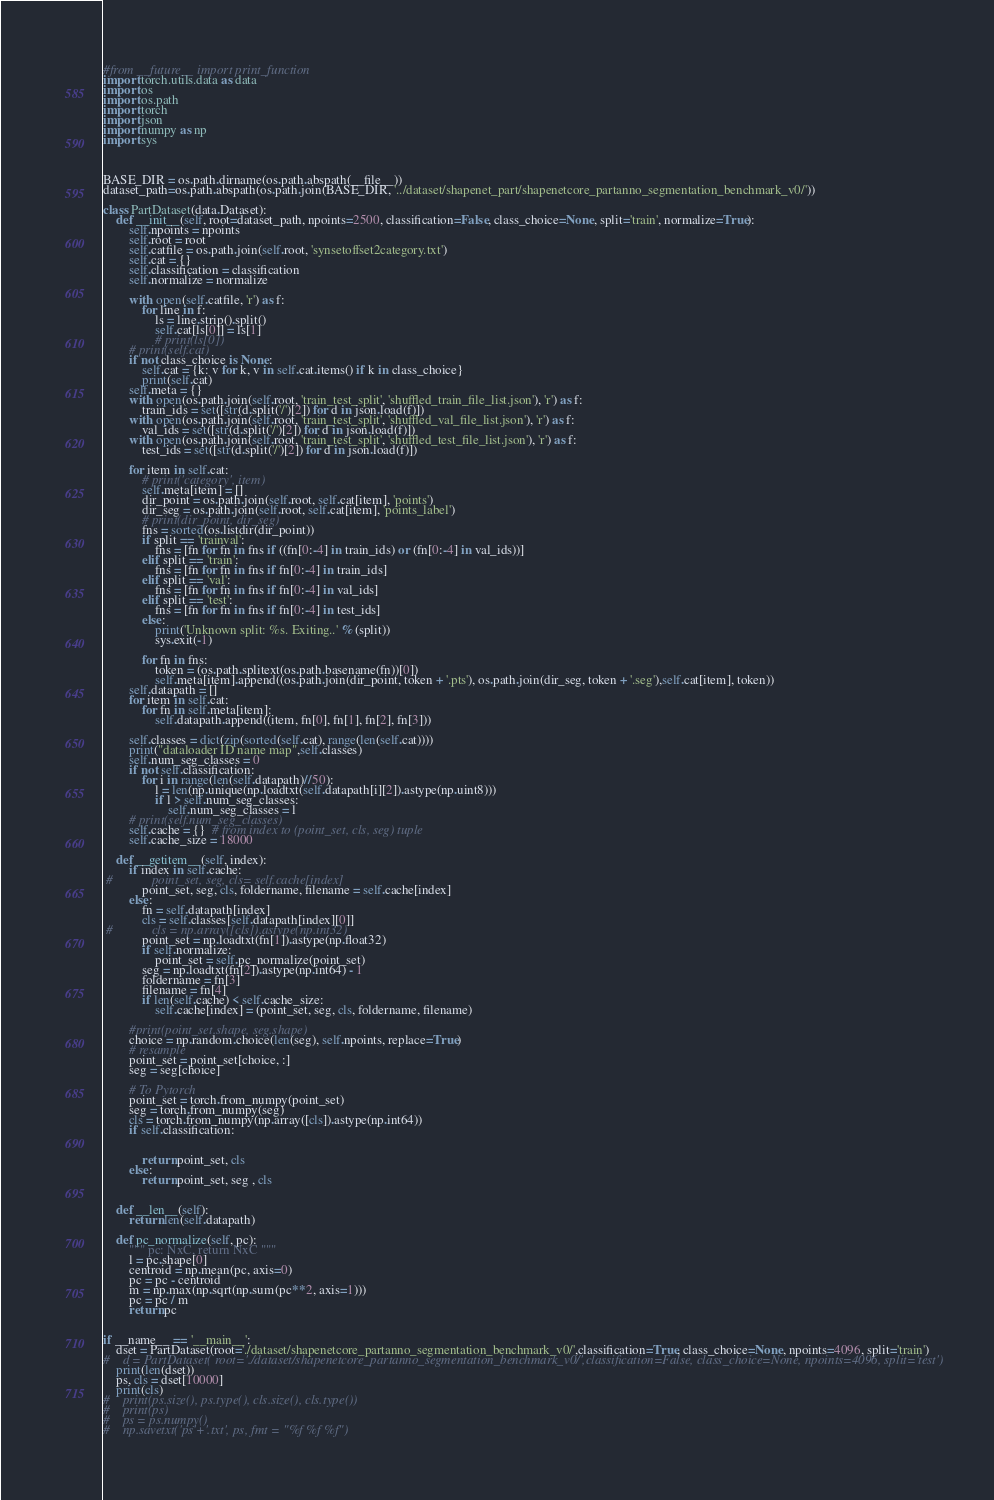<code> <loc_0><loc_0><loc_500><loc_500><_Python_>#from __future__ import print_function
import torch.utils.data as data
import os
import os.path
import torch
import json
import numpy as np
import sys



BASE_DIR = os.path.dirname(os.path.abspath(__file__))
dataset_path=os.path.abspath(os.path.join(BASE_DIR, '../dataset/shapenet_part/shapenetcore_partanno_segmentation_benchmark_v0/'))

class PartDataset(data.Dataset):
    def __init__(self, root=dataset_path, npoints=2500, classification=False, class_choice=None, split='train', normalize=True):
        self.npoints = npoints
        self.root = root
        self.catfile = os.path.join(self.root, 'synsetoffset2category.txt')
        self.cat = {}
        self.classification = classification
        self.normalize = normalize

        with open(self.catfile, 'r') as f:
            for line in f:
                ls = line.strip().split()
                self.cat[ls[0]] = ls[1]
                # print(ls[0])
        # print(self.cat)
        if not class_choice is None:
            self.cat = {k: v for k, v in self.cat.items() if k in class_choice}
            print(self.cat)
        self.meta = {}
        with open(os.path.join(self.root, 'train_test_split', 'shuffled_train_file_list.json'), 'r') as f:
            train_ids = set([str(d.split('/')[2]) for d in json.load(f)])
        with open(os.path.join(self.root, 'train_test_split', 'shuffled_val_file_list.json'), 'r') as f:
            val_ids = set([str(d.split('/')[2]) for d in json.load(f)])
        with open(os.path.join(self.root, 'train_test_split', 'shuffled_test_file_list.json'), 'r') as f:
            test_ids = set([str(d.split('/')[2]) for d in json.load(f)])

        for item in self.cat:
            # print('category', item)
            self.meta[item] = []
            dir_point = os.path.join(self.root, self.cat[item], 'points')
            dir_seg = os.path.join(self.root, self.cat[item], 'points_label')
            # print(dir_point, dir_seg)
            fns = sorted(os.listdir(dir_point))
            if split == 'trainval':
                fns = [fn for fn in fns if ((fn[0:-4] in train_ids) or (fn[0:-4] in val_ids))]
            elif split == 'train':
                fns = [fn for fn in fns if fn[0:-4] in train_ids]
            elif split == 'val':
                fns = [fn for fn in fns if fn[0:-4] in val_ids]
            elif split == 'test':
                fns = [fn for fn in fns if fn[0:-4] in test_ids]
            else:
                print('Unknown split: %s. Exiting..' % (split))
                sys.exit(-1)

            for fn in fns:
                token = (os.path.splitext(os.path.basename(fn))[0])
                self.meta[item].append((os.path.join(dir_point, token + '.pts'), os.path.join(dir_seg, token + '.seg'),self.cat[item], token))            
        self.datapath = []
        for item in self.cat:
            for fn in self.meta[item]:
                self.datapath.append((item, fn[0], fn[1], fn[2], fn[3]))

        self.classes = dict(zip(sorted(self.cat), range(len(self.cat))))
        print("dataloader ID name map",self.classes)
        self.num_seg_classes = 0
        if not self.classification:
            for i in range(len(self.datapath)//50):
                l = len(np.unique(np.loadtxt(self.datapath[i][2]).astype(np.uint8)))
                if l > self.num_seg_classes:
                    self.num_seg_classes = l
        # print(self.num_seg_classes)
        self.cache = {}  # from index to (point_set, cls, seg) tuple
        self.cache_size = 18000

    def __getitem__(self, index):
        if index in self.cache:
 #            point_set, seg, cls= self.cache[index]
            point_set, seg, cls, foldername, filename = self.cache[index]
        else:
            fn = self.datapath[index]
            cls = self.classes[self.datapath[index][0]]
 #            cls = np.array([cls]).astype(np.int32)
            point_set = np.loadtxt(fn[1]).astype(np.float32)
            if self.normalize:
                point_set = self.pc_normalize(point_set)
            seg = np.loadtxt(fn[2]).astype(np.int64) - 1
            foldername = fn[3]
            filename = fn[4]
            if len(self.cache) < self.cache_size:
                self.cache[index] = (point_set, seg, cls, foldername, filename)

        #print(point_set.shape, seg.shape)
        choice = np.random.choice(len(seg), self.npoints, replace=True)
        # resample
        point_set = point_set[choice, :]
        seg = seg[choice]
        
        # To Pytorch
        point_set = torch.from_numpy(point_set)
        seg = torch.from_numpy(seg)
        cls = torch.from_numpy(np.array([cls]).astype(np.int64))
        if self.classification:
            
            
            return point_set, cls
        else:
            return point_set, seg , cls
        

    def __len__(self):
        return len(self.datapath)
       
    def pc_normalize(self, pc):
        """ pc: NxC, return NxC """
        l = pc.shape[0]
        centroid = np.mean(pc, axis=0)
        pc = pc - centroid
        m = np.max(np.sqrt(np.sum(pc**2, axis=1)))
        pc = pc / m
        return pc


if __name__ == '__main__':
    dset = PartDataset(root='./dataset/shapenetcore_partanno_segmentation_benchmark_v0/',classification=True, class_choice=None, npoints=4096, split='train')
#    d = PartDataset( root='./dataset/shapenetcore_partanno_segmentation_benchmark_v0/',classification=False, class_choice=None, npoints=4096, split='test')
    print(len(dset))
    ps, cls = dset[10000]
    print(cls)
#    print(ps.size(), ps.type(), cls.size(), cls.type())
#    print(ps)
#    ps = ps.numpy()
#    np.savetxt('ps'+'.txt', ps, fmt = "%f %f %f")
</code> 